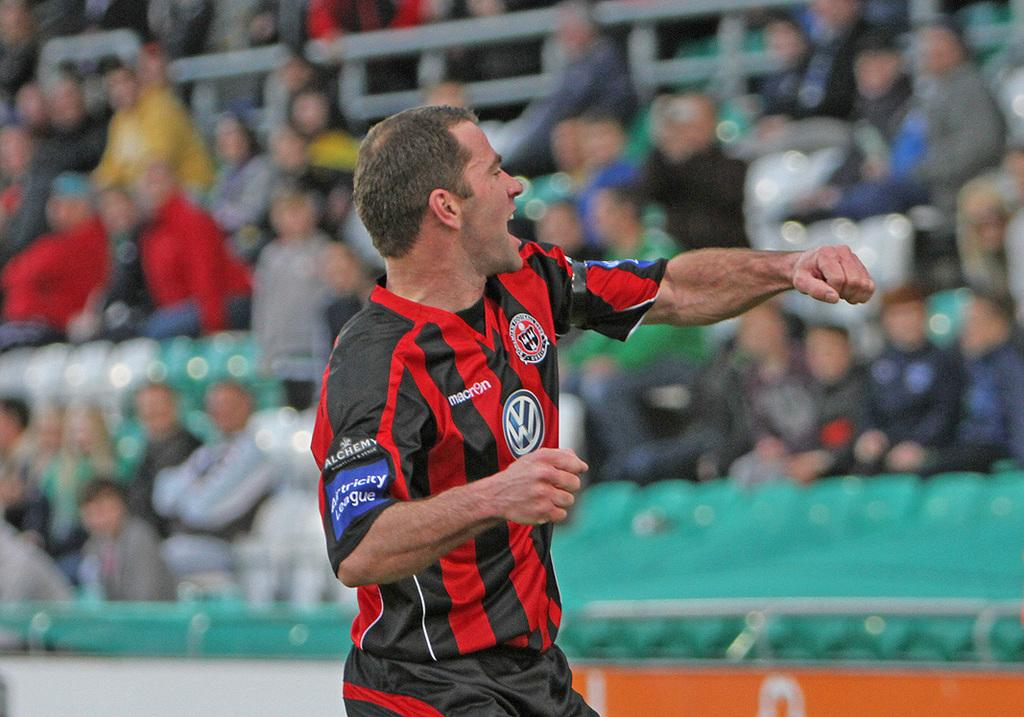<image>
Render a clear and concise summary of the photo. a man that has a Volkswagen on his shirt 